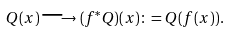Convert formula to latex. <formula><loc_0><loc_0><loc_500><loc_500>Q ( x ) \longrightarrow ( f ^ { * } Q ) ( x ) \colon = Q ( f ( x ) ) .</formula> 